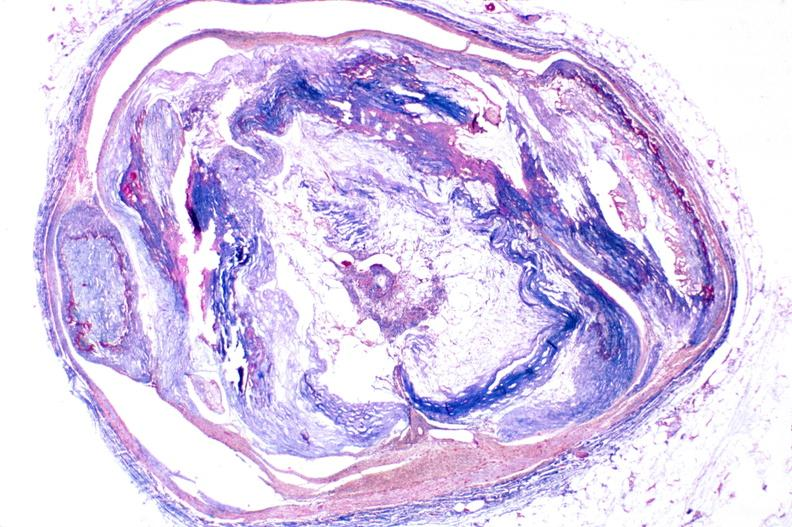where is this in?
Answer the question using a single word or phrase. In vasculature 